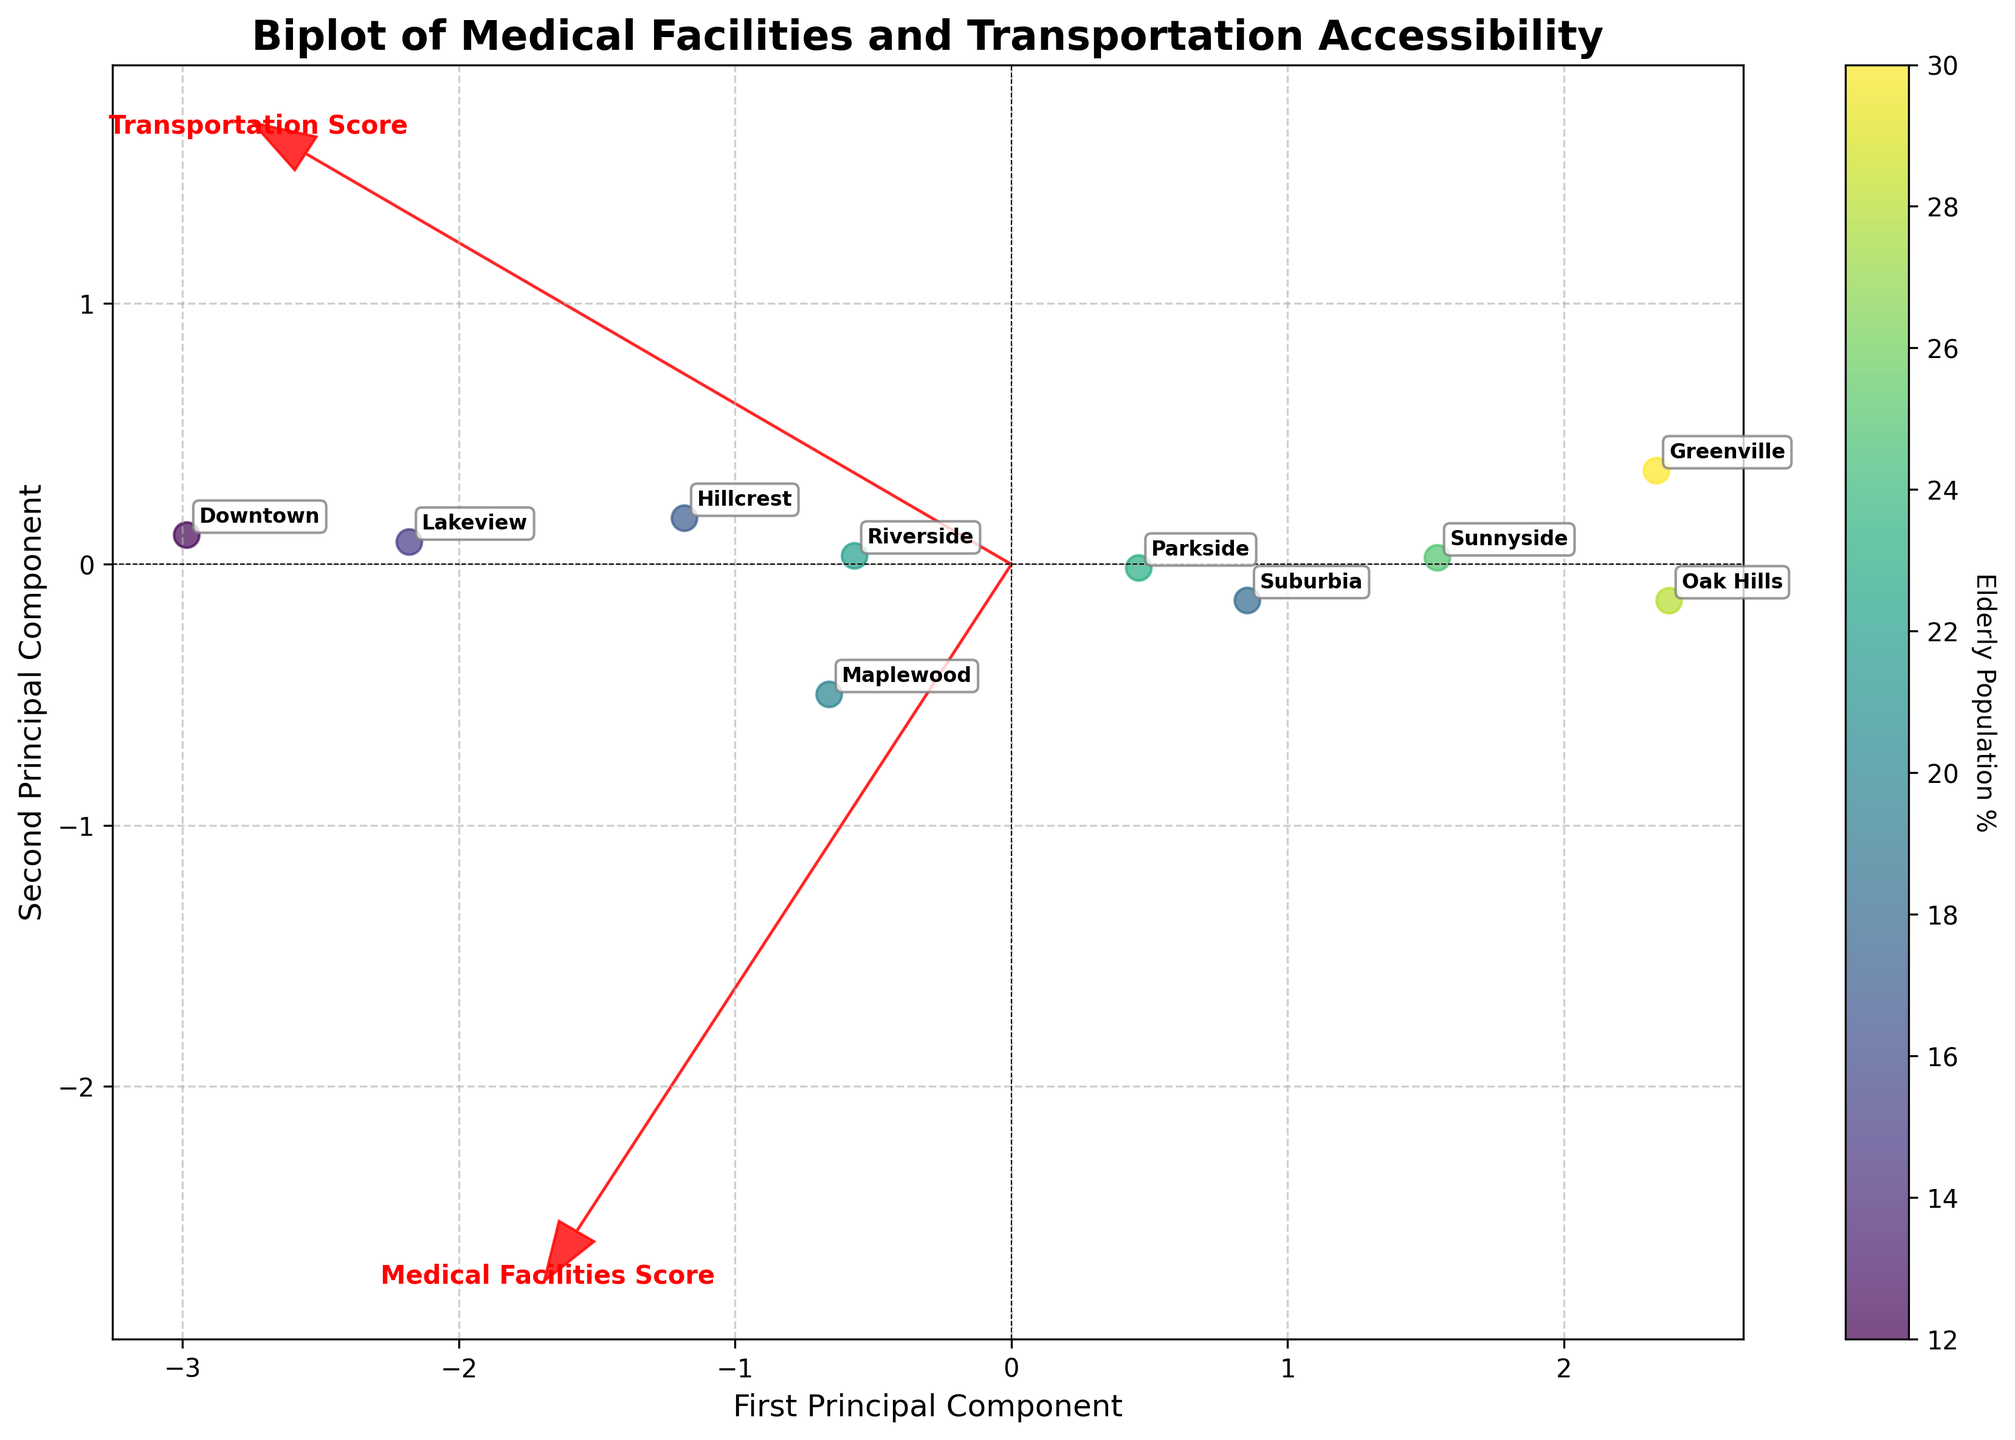What's the title of the figure? The title is usually written at the top of the figure and provides an overview of what the plot represents. Here, the title is "Biplot of Medical Facilities and Transportation Accessibility".
Answer: Biplot of Medical Facilities and Transportation Accessibility What do the arrows represent in the biplot? Arrows in a biplot indicate the direction and strength of the variables used in the PCA, namely 'Medical Facilities Score' and 'Transportation Score'. They show how much each variable contributes to the principal components.
Answer: Medical Facilities Score and Transportation Score Which neighborhood has the highest 'Elderly Population %'? To find the neighborhood with the highest elderly population percentage, look at the color gradient. Darker colors represent higher percentages. 'Greenville' is the darkest, indicating the highest percentage.
Answer: Greenville Which neighborhood is the closest to the origin along both principal components? To determine which neighborhood is closest to the origin, look for the point nearest (0,0) on the plot. 'Downtown' is the point closest to the origin along both principal components.
Answer: Downtown How many neighborhoods have a shuttle service available? Check the figure annotations and look for neighborhoods labeled in close proximity to areas clustered based on shuttle service availability. There should be three such neighborhoods: Downtown, Riverside, and Maplewood.
Answer: 3 What does the color of the dots represent in the plot? The color gradient of the dots (ranging from light to dark) represents the 'Elderly Population %'. Darker dots indicate a higher percentage of elderly population in the neighborhood.
Answer: Elderly Population % Which neighborhood has the lowest 'Medical Facilities Score' and how does its 'Transportation Score' compare? Identify the neighborhood with the lowest 'Medical Facilities Score' (look at the directional arrows and the axis). 'Greenville' has the lowest score. Check its position relative to the 'Transportation Score' vector—it also has a low transportation score.
Answer: Greenville; low_transportation_score Which neighborhood shows a high 'Medical Facilities Score' but a low 'Transportation Score'? Locate the neighborhoods with high 'Medical Facilities Scores' (positive direction along the corresponding vector) and then check their position relative to the 'Transportation Score' vector. 'Lakeview' fits this description.
Answer: Lakeview Can you identify a neighborhood with both high 'Medical Facilities Score' and high 'Transportation Score'? Look for a neighborhood that is positioned positively along both vectors for 'Medical Facilities Score' and 'Transportation Score'. 'Downtown' stands out as high in both scores.
Answer: Downtown What's the average 'Medical Facilities Score' for neighborhoods without shuttle service availability? To find this, identify the neighborhoods without shuttle services (Suburbia, Sunnyside, Parkside), then average their scores: (6.7 + 6.2 + 6.8) / 3 = 6.57.
Answer: 6.57 